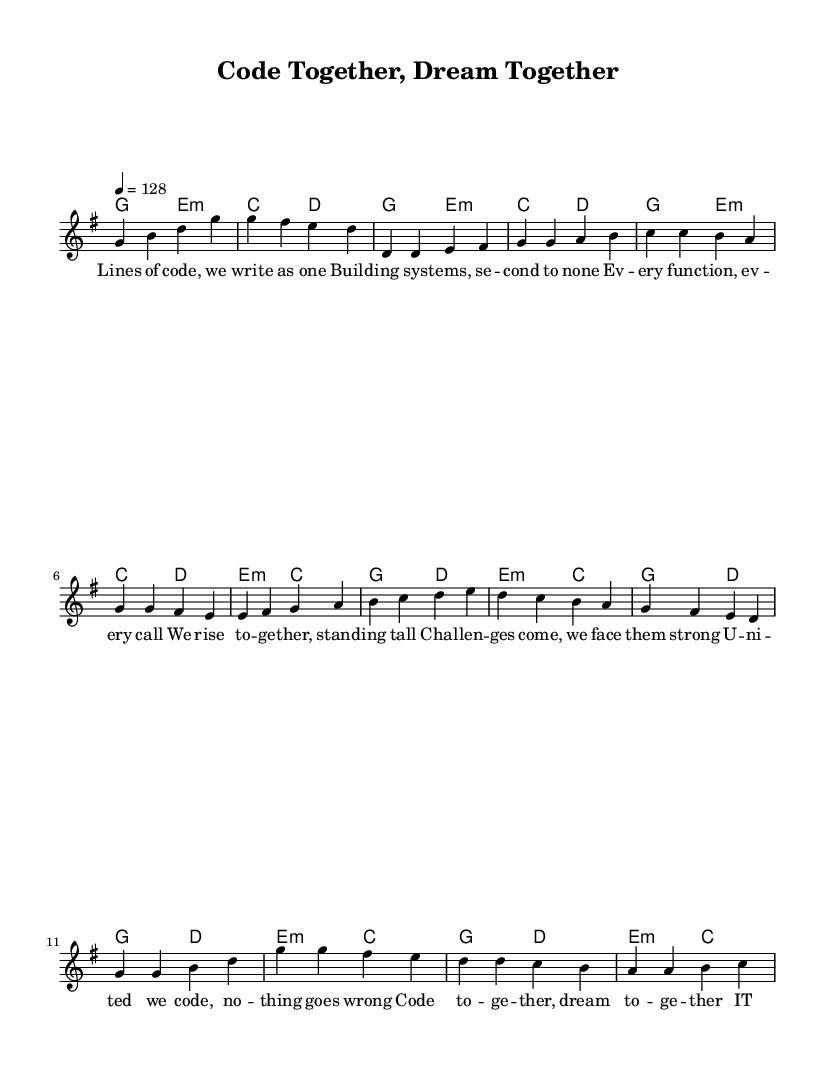What is the key signature of this music? The key signature is G major, which has one sharp (F#). This can be determined by looking at the number of sharps indicated in the key signature at the beginning of the score.
Answer: G major What is the time signature of this music? The time signature is four-four, indicated by the notation '4/4' in the score. This means there are four beats in each measure and a quarter note receives one beat.
Answer: Four-four What is the tempo of this music? The tempo is 128 beats per minute, as indicated by the tempo marking in the score. This gives an indication of how fast the piece should be performed.
Answer: 128 How many sections does the piece have? The piece consists of three main sections: the Verse, Pre-Chorus, and Chorus, as outlined in the lyrics and indicated in the structure of the music.
Answer: Three In which section do the lyrics mention "united we code"? The lyrics "united we code" are found in the Pre-Chorus section. This can be identified by matching the lyrics with their appropriate musical section as labeled in the score.
Answer: Pre-Chorus What thematic element does the song emphasize? The song emphasizes teamwork and collaboration, as illustrated by lyrics that focus on coding together and facing challenges as a united team. This is typical of K-Pop anthems that promote unity and positivity.
Answer: Teamwork 